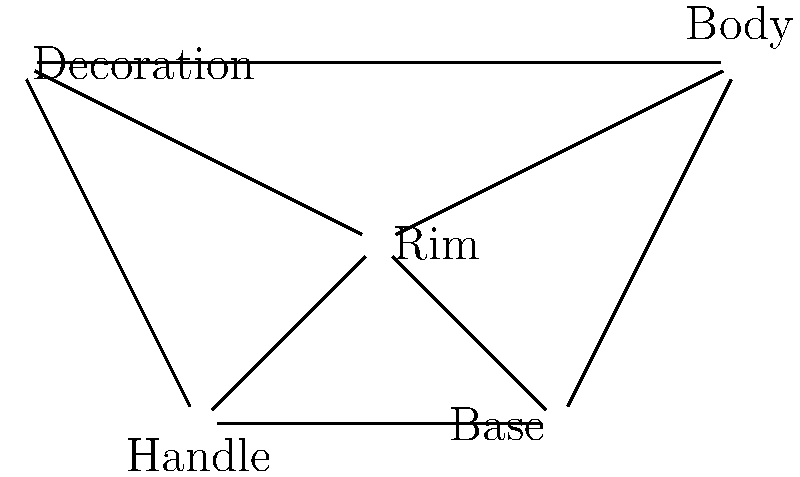In the network diagram representing pottery sherd classification, which node has the highest degree centrality, and how many connections does it have? To determine the node with the highest degree centrality and count its connections, we need to follow these steps:

1. Identify all nodes in the network:
   - Rim
   - Body
   - Base
   - Handle
   - Decoration

2. Count the number of connections (edges) for each node:
   - Rim: 4 connections (to Body, Base, Handle, and Decoration)
   - Body: 3 connections (to Rim, Base, and Decoration)
   - Base: 3 connections (to Rim, Body, and Handle)
   - Handle: 3 connections (to Rim, Base, and Decoration)
   - Decoration: 3 connections (to Rim, Body, and Handle)

3. Identify the node with the highest number of connections:
   The Rim node has 4 connections, which is the highest among all nodes.

4. Express the result:
   The node with the highest degree centrality is Rim, with 4 connections.
Answer: Rim, 4 